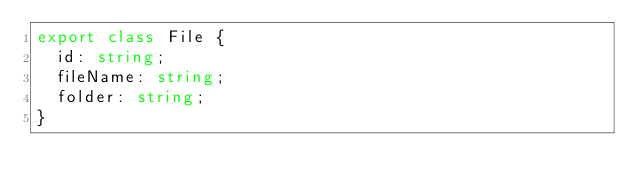<code> <loc_0><loc_0><loc_500><loc_500><_TypeScript_>export class File {
  id: string;
  fileName: string;
  folder: string;
}
</code> 